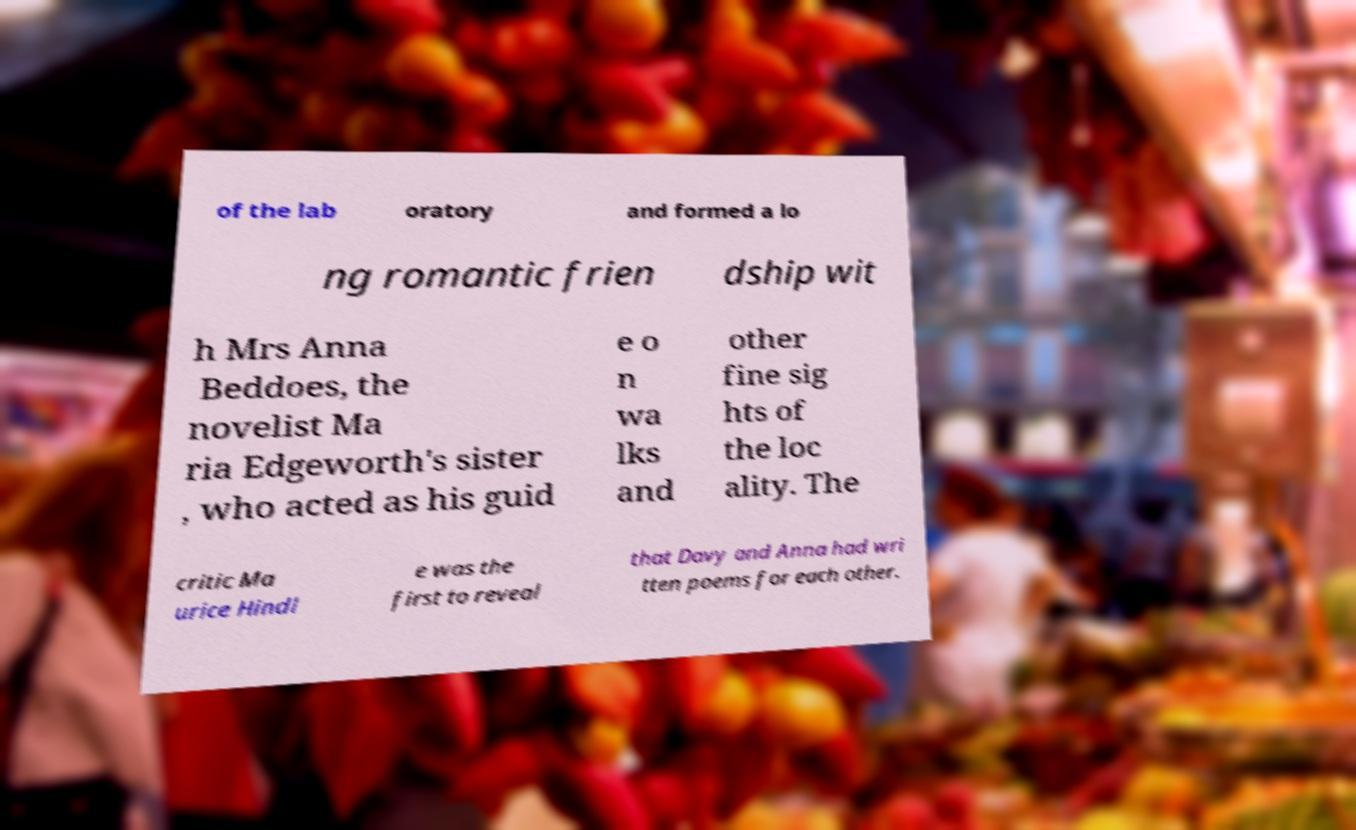There's text embedded in this image that I need extracted. Can you transcribe it verbatim? of the lab oratory and formed a lo ng romantic frien dship wit h Mrs Anna Beddoes, the novelist Ma ria Edgeworth's sister , who acted as his guid e o n wa lks and other fine sig hts of the loc ality. The critic Ma urice Hindl e was the first to reveal that Davy and Anna had wri tten poems for each other. 